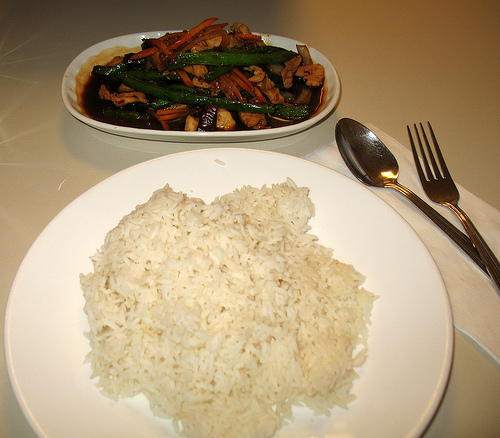<image>
Is the plate under the rice? Yes. The plate is positioned underneath the rice, with the rice above it in the vertical space. 